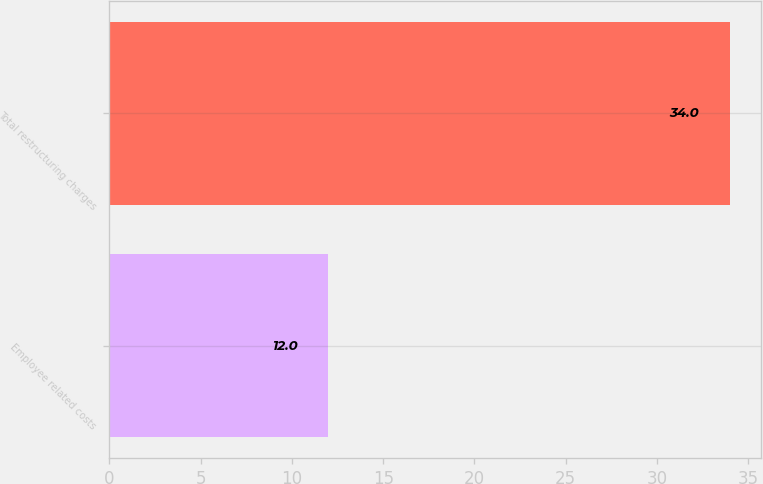Convert chart. <chart><loc_0><loc_0><loc_500><loc_500><bar_chart><fcel>Employee related costs<fcel>Total restructuring charges<nl><fcel>12<fcel>34<nl></chart> 